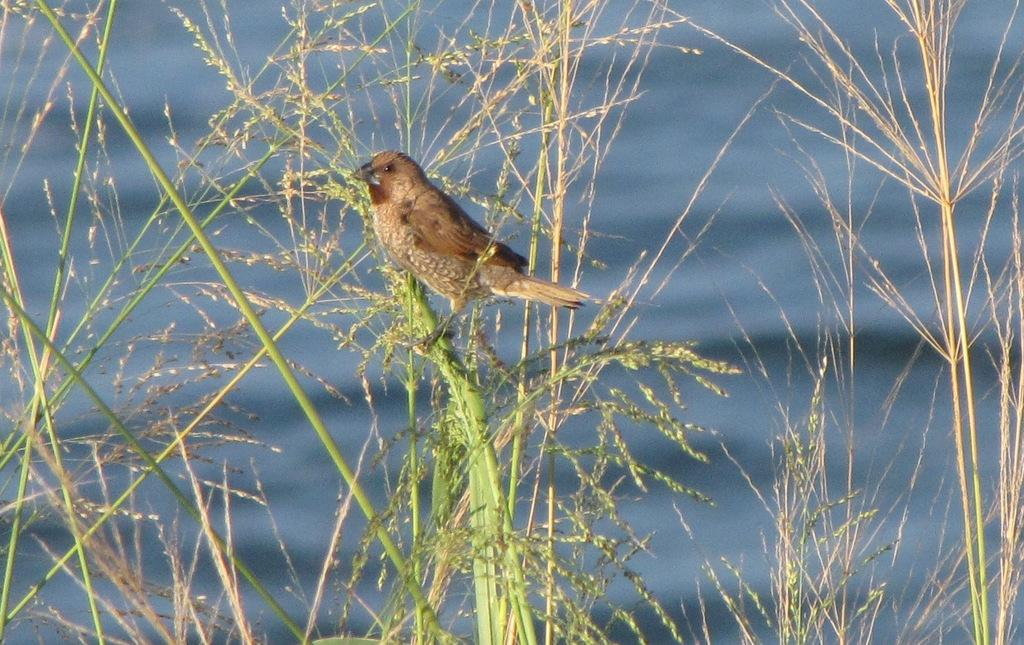What type of animal is in the image? There is a small brown bird in the image. Where is the bird located in the image? The bird is sitting on a plant branch. What color is the thread that the bird is using to wave at its father in the image? There is no thread, wave, or father present in the image; it only features a small brown bird sitting on a plant branch. 